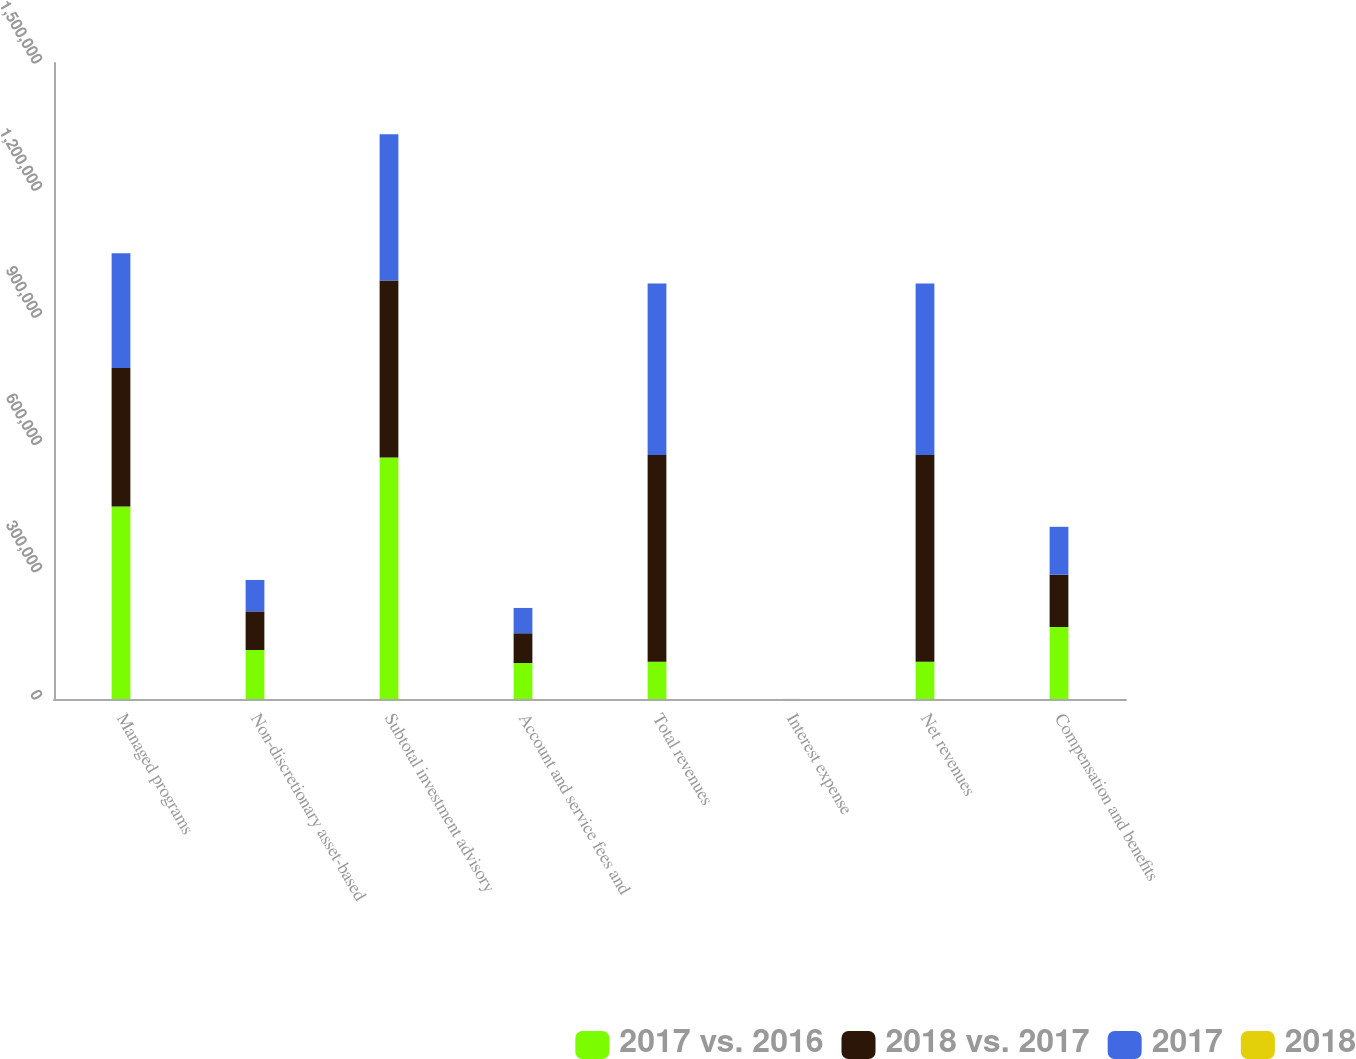<chart> <loc_0><loc_0><loc_500><loc_500><stacked_bar_chart><ecel><fcel>Managed programs<fcel>Non-discretionary asset-based<fcel>Subtotal investment advisory<fcel>Account and service fees and<fcel>Total revenues<fcel>Interest expense<fcel>Net revenues<fcel>Compensation and benefits<nl><fcel>2017 vs. 2016<fcel>454027<fcel>115562<fcel>569589<fcel>84829<fcel>87958<fcel>41<fcel>87958<fcel>169993<nl><fcel>2018 vs. 2017<fcel>326405<fcel>91087<fcel>417492<fcel>70243<fcel>487735<fcel>77<fcel>487658<fcel>123119<nl><fcel>2017<fcel>270623<fcel>74130<fcel>344753<fcel>59668<fcel>404421<fcel>72<fcel>404349<fcel>112998<nl><fcel>2018<fcel>39<fcel>27<fcel>36<fcel>21<fcel>34<fcel>47<fcel>34<fcel>38<nl></chart> 